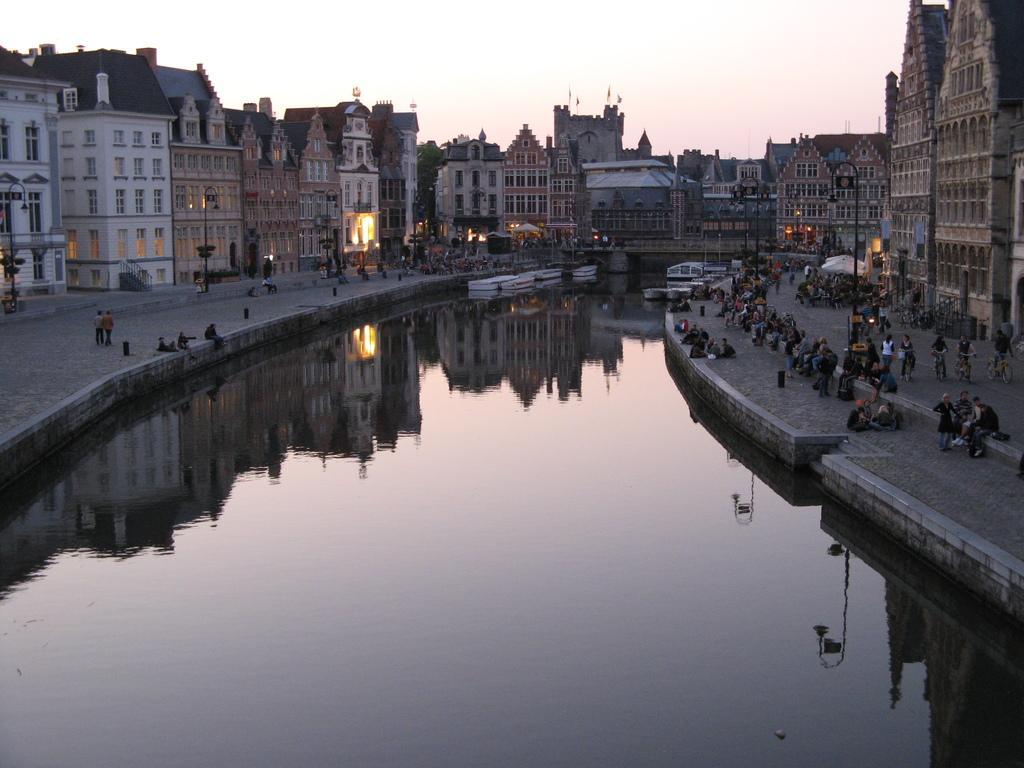In one or two sentences, can you explain what this image depicts? In the center of the image there is water in the center of the image. To both sides of the image there are buildings. There are people. There is a bridge. 